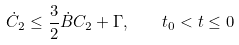<formula> <loc_0><loc_0><loc_500><loc_500>\dot { C } _ { 2 } \leq \frac { 3 } { 2 } \dot { B } C _ { 2 } + \Gamma , \quad t _ { 0 } < t \leq 0</formula> 